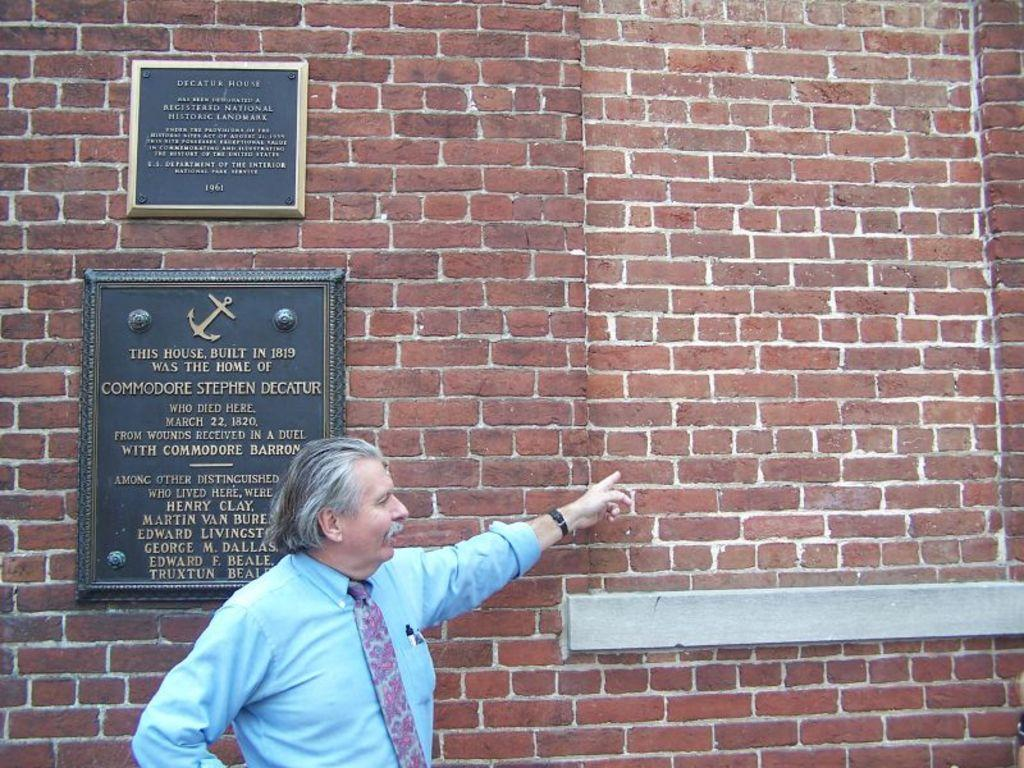Who is the main subject in the foreground of the picture? There is a man in the foreground of the picture. What is the man wearing in the image? The man is wearing a sky blue shirt. What is the man doing in the image? The man is showing a finger to a brick wall. What can be seen attached to the brick wall in the image? There are two name boards attached to the brick wall. What type of crate is visible in the image? There is no crate present in the image. How does the man tie a knot in the image? The man is not tying a knot in the image; he is showing a finger to a brick wall. 